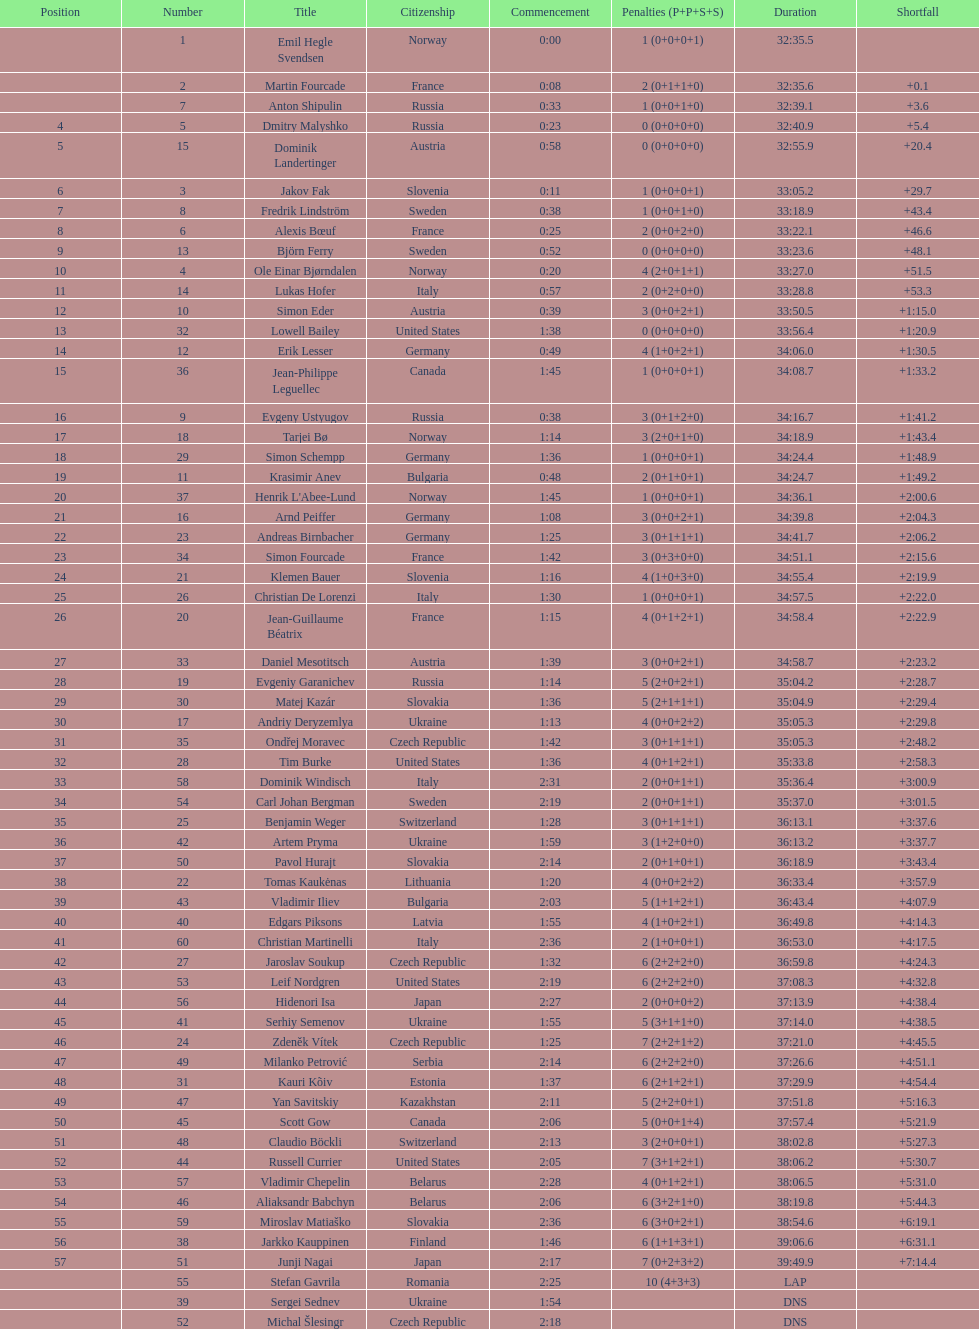What is the number of russian participants? 4. 